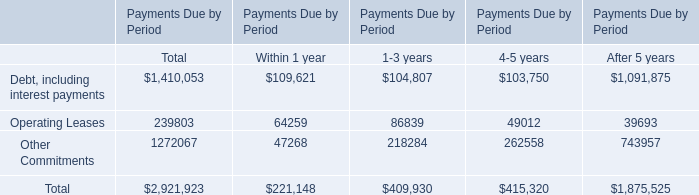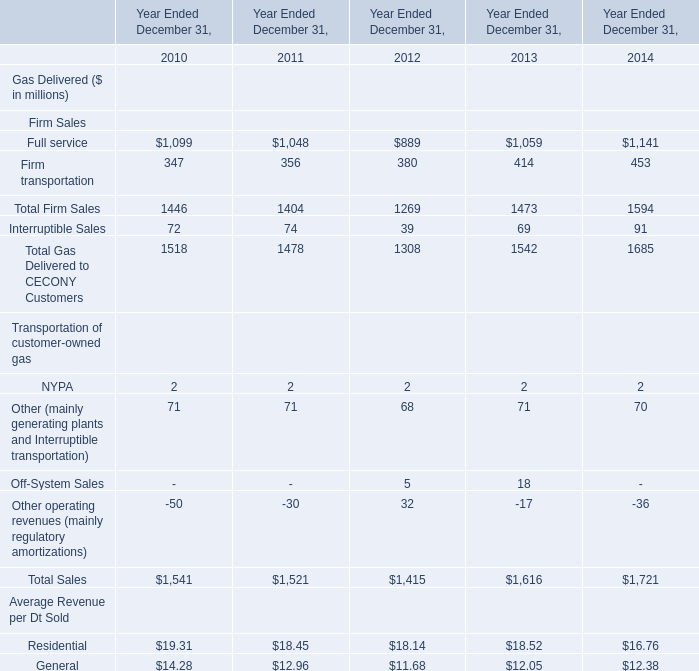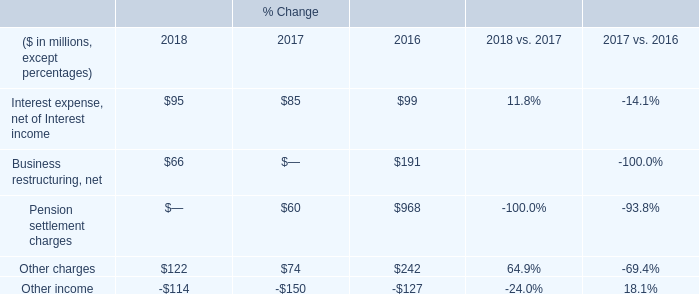what was the total pre-tax restructuring program cost in millions? 
Computations: ((83 - 17) + 191)
Answer: 257.0. 